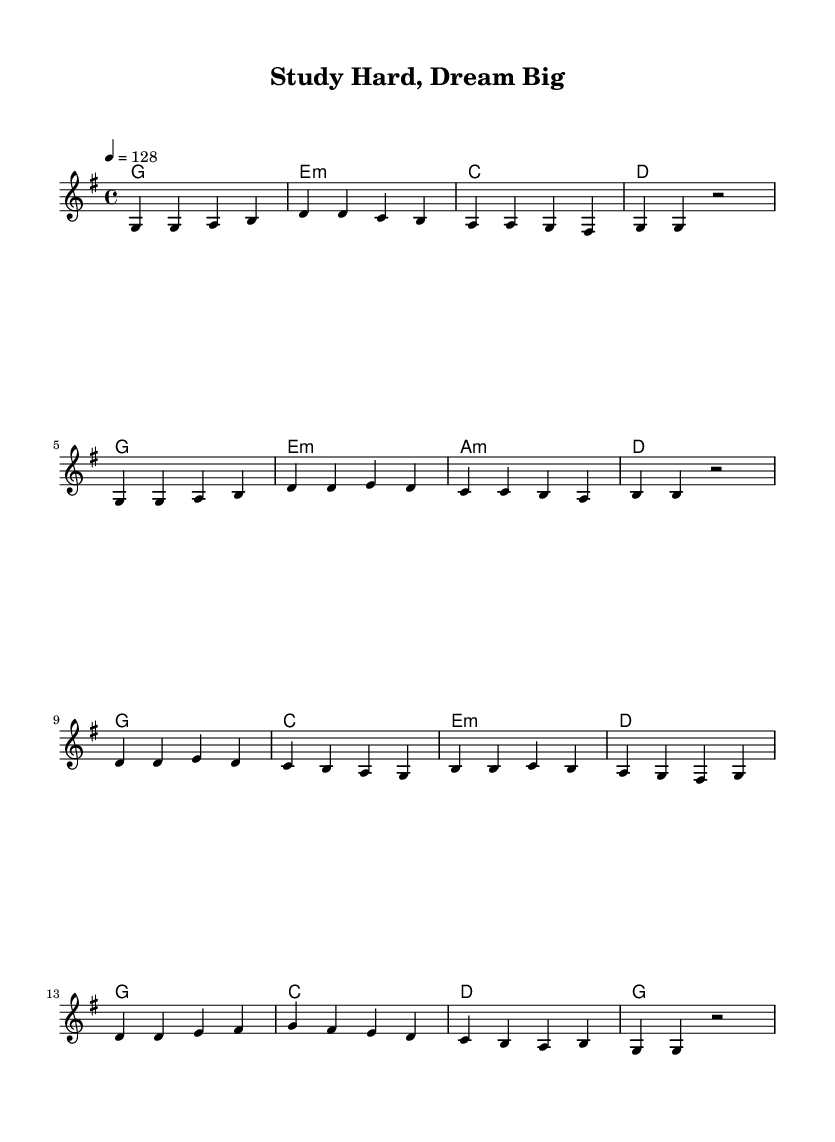What is the key signature of this music? The key signature is G major, which has one sharp (F#).
Answer: G major What is the time signature of this music? The time signature is 4/4, indicating four beats per measure.
Answer: 4/4 What is the tempo marking of this piece? The tempo marking indicates a speed of 128 beats per minute.
Answer: 128 How many measures are in the verse section? The verse section consists of 8 measures as indicated by the grouped musical phrases.
Answer: 8 What is the final chord of the chorus? The final chord of the chorus is G major, as indicated by the last chord symbol present.
Answer: G What is the main theme of the lyrics as suggested by the title? The title "Study Hard, Dream Big" suggests a focus on motivation and perseverance.
Answer: Motivation and perseverance How is the chord progression structured in the chorus? The chord progression in the chorus follows a pattern of G, C, E minor, D, then repeats with variations.
Answer: G, C, E minor, D 